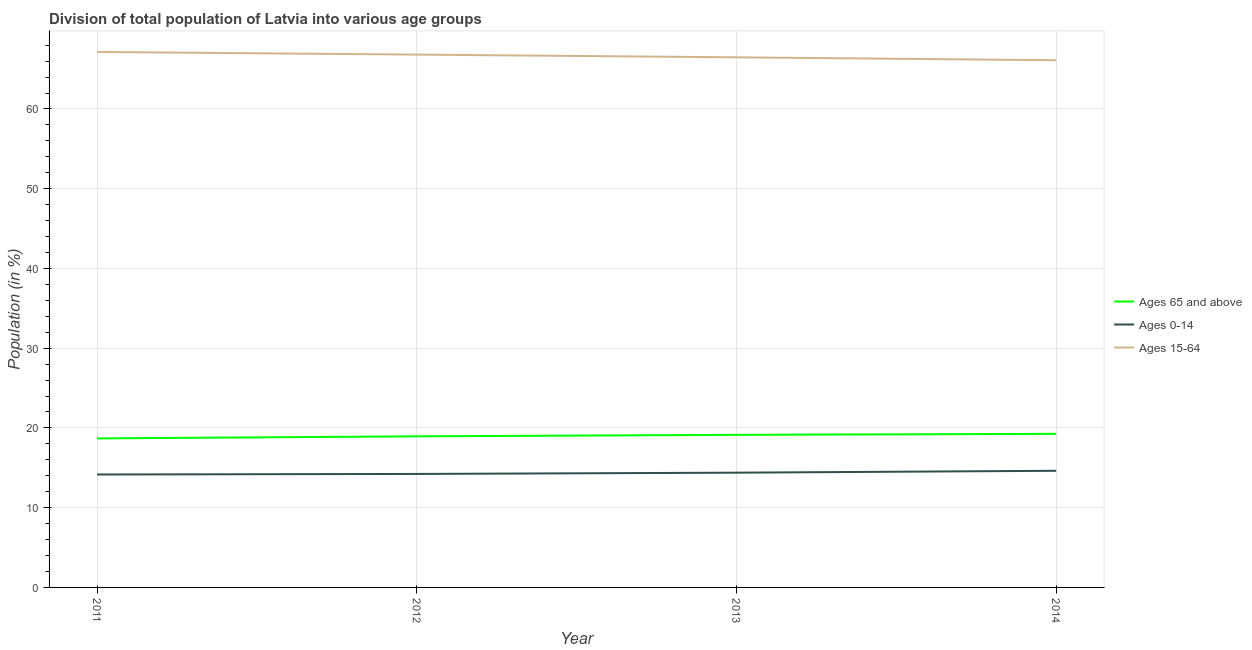How many different coloured lines are there?
Give a very brief answer. 3. What is the percentage of population within the age-group of 65 and above in 2012?
Provide a succinct answer. 18.95. Across all years, what is the maximum percentage of population within the age-group 0-14?
Keep it short and to the point. 14.63. Across all years, what is the minimum percentage of population within the age-group of 65 and above?
Make the answer very short. 18.69. In which year was the percentage of population within the age-group of 65 and above minimum?
Offer a very short reply. 2011. What is the total percentage of population within the age-group of 65 and above in the graph?
Your response must be concise. 76.03. What is the difference between the percentage of population within the age-group of 65 and above in 2011 and that in 2014?
Give a very brief answer. -0.57. What is the difference between the percentage of population within the age-group 0-14 in 2013 and the percentage of population within the age-group 15-64 in 2012?
Your answer should be compact. -52.43. What is the average percentage of population within the age-group 15-64 per year?
Keep it short and to the point. 66.64. In the year 2012, what is the difference between the percentage of population within the age-group 0-14 and percentage of population within the age-group of 65 and above?
Provide a short and direct response. -4.72. What is the ratio of the percentage of population within the age-group 15-64 in 2012 to that in 2013?
Provide a succinct answer. 1.01. Is the percentage of population within the age-group of 65 and above in 2012 less than that in 2014?
Offer a terse response. Yes. What is the difference between the highest and the second highest percentage of population within the age-group 15-64?
Offer a terse response. 0.33. What is the difference between the highest and the lowest percentage of population within the age-group 0-14?
Provide a succinct answer. 0.47. Does the percentage of population within the age-group of 65 and above monotonically increase over the years?
Keep it short and to the point. Yes. How many lines are there?
Offer a terse response. 3. What is the title of the graph?
Provide a short and direct response. Division of total population of Latvia into various age groups
. Does "Total employers" appear as one of the legend labels in the graph?
Provide a short and direct response. No. What is the Population (in %) of Ages 65 and above in 2011?
Your response must be concise. 18.69. What is the Population (in %) in Ages 0-14 in 2011?
Your answer should be compact. 14.16. What is the Population (in %) in Ages 15-64 in 2011?
Give a very brief answer. 67.15. What is the Population (in %) of Ages 65 and above in 2012?
Offer a very short reply. 18.95. What is the Population (in %) of Ages 0-14 in 2012?
Your answer should be compact. 14.23. What is the Population (in %) in Ages 15-64 in 2012?
Provide a short and direct response. 66.82. What is the Population (in %) of Ages 65 and above in 2013?
Keep it short and to the point. 19.13. What is the Population (in %) of Ages 0-14 in 2013?
Give a very brief answer. 14.39. What is the Population (in %) of Ages 15-64 in 2013?
Offer a very short reply. 66.48. What is the Population (in %) in Ages 65 and above in 2014?
Offer a terse response. 19.26. What is the Population (in %) of Ages 0-14 in 2014?
Offer a terse response. 14.63. What is the Population (in %) of Ages 15-64 in 2014?
Give a very brief answer. 66.11. Across all years, what is the maximum Population (in %) in Ages 65 and above?
Your answer should be very brief. 19.26. Across all years, what is the maximum Population (in %) of Ages 0-14?
Give a very brief answer. 14.63. Across all years, what is the maximum Population (in %) of Ages 15-64?
Your response must be concise. 67.15. Across all years, what is the minimum Population (in %) of Ages 65 and above?
Give a very brief answer. 18.69. Across all years, what is the minimum Population (in %) in Ages 0-14?
Provide a succinct answer. 14.16. Across all years, what is the minimum Population (in %) of Ages 15-64?
Ensure brevity in your answer.  66.11. What is the total Population (in %) of Ages 65 and above in the graph?
Provide a short and direct response. 76.03. What is the total Population (in %) in Ages 0-14 in the graph?
Offer a very short reply. 57.41. What is the total Population (in %) in Ages 15-64 in the graph?
Ensure brevity in your answer.  266.56. What is the difference between the Population (in %) of Ages 65 and above in 2011 and that in 2012?
Ensure brevity in your answer.  -0.26. What is the difference between the Population (in %) in Ages 0-14 in 2011 and that in 2012?
Offer a very short reply. -0.07. What is the difference between the Population (in %) in Ages 15-64 in 2011 and that in 2012?
Keep it short and to the point. 0.33. What is the difference between the Population (in %) in Ages 65 and above in 2011 and that in 2013?
Give a very brief answer. -0.45. What is the difference between the Population (in %) of Ages 0-14 in 2011 and that in 2013?
Your answer should be compact. -0.23. What is the difference between the Population (in %) of Ages 15-64 in 2011 and that in 2013?
Give a very brief answer. 0.68. What is the difference between the Population (in %) in Ages 65 and above in 2011 and that in 2014?
Offer a terse response. -0.57. What is the difference between the Population (in %) in Ages 0-14 in 2011 and that in 2014?
Provide a succinct answer. -0.47. What is the difference between the Population (in %) in Ages 15-64 in 2011 and that in 2014?
Offer a terse response. 1.04. What is the difference between the Population (in %) in Ages 65 and above in 2012 and that in 2013?
Keep it short and to the point. -0.18. What is the difference between the Population (in %) in Ages 0-14 in 2012 and that in 2013?
Your answer should be very brief. -0.16. What is the difference between the Population (in %) of Ages 15-64 in 2012 and that in 2013?
Your response must be concise. 0.34. What is the difference between the Population (in %) of Ages 65 and above in 2012 and that in 2014?
Your response must be concise. -0.31. What is the difference between the Population (in %) in Ages 0-14 in 2012 and that in 2014?
Your answer should be compact. -0.4. What is the difference between the Population (in %) of Ages 15-64 in 2012 and that in 2014?
Your answer should be very brief. 0.71. What is the difference between the Population (in %) in Ages 65 and above in 2013 and that in 2014?
Your response must be concise. -0.13. What is the difference between the Population (in %) of Ages 0-14 in 2013 and that in 2014?
Offer a very short reply. -0.24. What is the difference between the Population (in %) of Ages 15-64 in 2013 and that in 2014?
Your answer should be very brief. 0.36. What is the difference between the Population (in %) of Ages 65 and above in 2011 and the Population (in %) of Ages 0-14 in 2012?
Your response must be concise. 4.46. What is the difference between the Population (in %) in Ages 65 and above in 2011 and the Population (in %) in Ages 15-64 in 2012?
Your answer should be compact. -48.13. What is the difference between the Population (in %) of Ages 0-14 in 2011 and the Population (in %) of Ages 15-64 in 2012?
Provide a succinct answer. -52.66. What is the difference between the Population (in %) in Ages 65 and above in 2011 and the Population (in %) in Ages 0-14 in 2013?
Your response must be concise. 4.3. What is the difference between the Population (in %) in Ages 65 and above in 2011 and the Population (in %) in Ages 15-64 in 2013?
Your answer should be compact. -47.79. What is the difference between the Population (in %) of Ages 0-14 in 2011 and the Population (in %) of Ages 15-64 in 2013?
Offer a terse response. -52.31. What is the difference between the Population (in %) of Ages 65 and above in 2011 and the Population (in %) of Ages 0-14 in 2014?
Give a very brief answer. 4.06. What is the difference between the Population (in %) of Ages 65 and above in 2011 and the Population (in %) of Ages 15-64 in 2014?
Your answer should be very brief. -47.42. What is the difference between the Population (in %) of Ages 0-14 in 2011 and the Population (in %) of Ages 15-64 in 2014?
Your response must be concise. -51.95. What is the difference between the Population (in %) in Ages 65 and above in 2012 and the Population (in %) in Ages 0-14 in 2013?
Ensure brevity in your answer.  4.56. What is the difference between the Population (in %) of Ages 65 and above in 2012 and the Population (in %) of Ages 15-64 in 2013?
Ensure brevity in your answer.  -47.53. What is the difference between the Population (in %) in Ages 0-14 in 2012 and the Population (in %) in Ages 15-64 in 2013?
Provide a short and direct response. -52.24. What is the difference between the Population (in %) in Ages 65 and above in 2012 and the Population (in %) in Ages 0-14 in 2014?
Offer a very short reply. 4.32. What is the difference between the Population (in %) in Ages 65 and above in 2012 and the Population (in %) in Ages 15-64 in 2014?
Offer a very short reply. -47.16. What is the difference between the Population (in %) in Ages 0-14 in 2012 and the Population (in %) in Ages 15-64 in 2014?
Your answer should be compact. -51.88. What is the difference between the Population (in %) in Ages 65 and above in 2013 and the Population (in %) in Ages 0-14 in 2014?
Give a very brief answer. 4.51. What is the difference between the Population (in %) of Ages 65 and above in 2013 and the Population (in %) of Ages 15-64 in 2014?
Give a very brief answer. -46.98. What is the difference between the Population (in %) of Ages 0-14 in 2013 and the Population (in %) of Ages 15-64 in 2014?
Offer a terse response. -51.72. What is the average Population (in %) in Ages 65 and above per year?
Your answer should be compact. 19.01. What is the average Population (in %) in Ages 0-14 per year?
Your answer should be very brief. 14.35. What is the average Population (in %) of Ages 15-64 per year?
Ensure brevity in your answer.  66.64. In the year 2011, what is the difference between the Population (in %) of Ages 65 and above and Population (in %) of Ages 0-14?
Offer a very short reply. 4.53. In the year 2011, what is the difference between the Population (in %) in Ages 65 and above and Population (in %) in Ages 15-64?
Your response must be concise. -48.46. In the year 2011, what is the difference between the Population (in %) in Ages 0-14 and Population (in %) in Ages 15-64?
Offer a very short reply. -52.99. In the year 2012, what is the difference between the Population (in %) in Ages 65 and above and Population (in %) in Ages 0-14?
Your response must be concise. 4.72. In the year 2012, what is the difference between the Population (in %) of Ages 65 and above and Population (in %) of Ages 15-64?
Make the answer very short. -47.87. In the year 2012, what is the difference between the Population (in %) in Ages 0-14 and Population (in %) in Ages 15-64?
Ensure brevity in your answer.  -52.59. In the year 2013, what is the difference between the Population (in %) in Ages 65 and above and Population (in %) in Ages 0-14?
Offer a very short reply. 4.74. In the year 2013, what is the difference between the Population (in %) of Ages 65 and above and Population (in %) of Ages 15-64?
Offer a terse response. -47.34. In the year 2013, what is the difference between the Population (in %) in Ages 0-14 and Population (in %) in Ages 15-64?
Provide a succinct answer. -52.09. In the year 2014, what is the difference between the Population (in %) in Ages 65 and above and Population (in %) in Ages 0-14?
Your response must be concise. 4.63. In the year 2014, what is the difference between the Population (in %) in Ages 65 and above and Population (in %) in Ages 15-64?
Your response must be concise. -46.85. In the year 2014, what is the difference between the Population (in %) in Ages 0-14 and Population (in %) in Ages 15-64?
Ensure brevity in your answer.  -51.48. What is the ratio of the Population (in %) in Ages 65 and above in 2011 to that in 2012?
Ensure brevity in your answer.  0.99. What is the ratio of the Population (in %) of Ages 15-64 in 2011 to that in 2012?
Provide a succinct answer. 1. What is the ratio of the Population (in %) of Ages 65 and above in 2011 to that in 2013?
Your answer should be compact. 0.98. What is the ratio of the Population (in %) in Ages 0-14 in 2011 to that in 2013?
Provide a succinct answer. 0.98. What is the ratio of the Population (in %) of Ages 15-64 in 2011 to that in 2013?
Your answer should be compact. 1.01. What is the ratio of the Population (in %) in Ages 65 and above in 2011 to that in 2014?
Your answer should be compact. 0.97. What is the ratio of the Population (in %) of Ages 0-14 in 2011 to that in 2014?
Provide a succinct answer. 0.97. What is the ratio of the Population (in %) of Ages 15-64 in 2011 to that in 2014?
Offer a terse response. 1.02. What is the ratio of the Population (in %) of Ages 65 and above in 2012 to that in 2013?
Your answer should be compact. 0.99. What is the ratio of the Population (in %) of Ages 65 and above in 2012 to that in 2014?
Provide a short and direct response. 0.98. What is the ratio of the Population (in %) of Ages 0-14 in 2012 to that in 2014?
Offer a terse response. 0.97. What is the ratio of the Population (in %) of Ages 15-64 in 2012 to that in 2014?
Your answer should be compact. 1.01. What is the ratio of the Population (in %) of Ages 65 and above in 2013 to that in 2014?
Offer a terse response. 0.99. What is the ratio of the Population (in %) of Ages 0-14 in 2013 to that in 2014?
Provide a succinct answer. 0.98. What is the difference between the highest and the second highest Population (in %) of Ages 65 and above?
Keep it short and to the point. 0.13. What is the difference between the highest and the second highest Population (in %) in Ages 0-14?
Your answer should be very brief. 0.24. What is the difference between the highest and the second highest Population (in %) in Ages 15-64?
Provide a succinct answer. 0.33. What is the difference between the highest and the lowest Population (in %) of Ages 65 and above?
Make the answer very short. 0.57. What is the difference between the highest and the lowest Population (in %) of Ages 0-14?
Provide a succinct answer. 0.47. What is the difference between the highest and the lowest Population (in %) of Ages 15-64?
Your response must be concise. 1.04. 